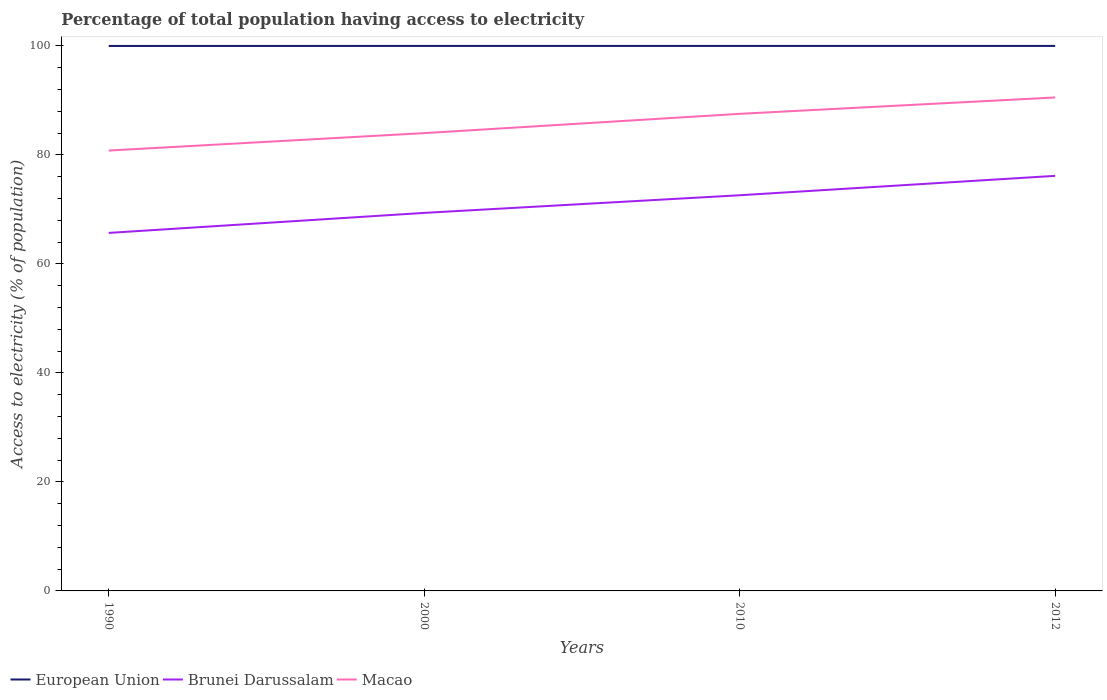How many different coloured lines are there?
Provide a short and direct response. 3. Is the number of lines equal to the number of legend labels?
Offer a very short reply. Yes. Across all years, what is the maximum percentage of population that have access to electricity in Macao?
Provide a succinct answer. 80.8. What is the total percentage of population that have access to electricity in European Union in the graph?
Keep it short and to the point. -0.01. What is the difference between the highest and the second highest percentage of population that have access to electricity in Brunei Darussalam?
Ensure brevity in your answer.  10.47. What is the difference between the highest and the lowest percentage of population that have access to electricity in Macao?
Provide a succinct answer. 2. How many lines are there?
Keep it short and to the point. 3. How many years are there in the graph?
Your answer should be very brief. 4. Are the values on the major ticks of Y-axis written in scientific E-notation?
Your response must be concise. No. Where does the legend appear in the graph?
Make the answer very short. Bottom left. How many legend labels are there?
Make the answer very short. 3. What is the title of the graph?
Offer a very short reply. Percentage of total population having access to electricity. Does "Europe(all income levels)" appear as one of the legend labels in the graph?
Your response must be concise. No. What is the label or title of the X-axis?
Your answer should be compact. Years. What is the label or title of the Y-axis?
Provide a succinct answer. Access to electricity (% of population). What is the Access to electricity (% of population) of European Union in 1990?
Offer a very short reply. 99.99. What is the Access to electricity (% of population) in Brunei Darussalam in 1990?
Give a very brief answer. 65.69. What is the Access to electricity (% of population) of Macao in 1990?
Provide a succinct answer. 80.8. What is the Access to electricity (% of population) in European Union in 2000?
Give a very brief answer. 100. What is the Access to electricity (% of population) of Brunei Darussalam in 2000?
Ensure brevity in your answer.  69.36. What is the Access to electricity (% of population) in European Union in 2010?
Ensure brevity in your answer.  100. What is the Access to electricity (% of population) of Brunei Darussalam in 2010?
Keep it short and to the point. 72.6. What is the Access to electricity (% of population) in Macao in 2010?
Make the answer very short. 87.54. What is the Access to electricity (% of population) in Brunei Darussalam in 2012?
Offer a very short reply. 76.16. What is the Access to electricity (% of population) of Macao in 2012?
Make the answer very short. 90.54. Across all years, what is the maximum Access to electricity (% of population) of European Union?
Your answer should be compact. 100. Across all years, what is the maximum Access to electricity (% of population) of Brunei Darussalam?
Offer a very short reply. 76.16. Across all years, what is the maximum Access to electricity (% of population) in Macao?
Make the answer very short. 90.54. Across all years, what is the minimum Access to electricity (% of population) of European Union?
Keep it short and to the point. 99.99. Across all years, what is the minimum Access to electricity (% of population) in Brunei Darussalam?
Your answer should be compact. 65.69. Across all years, what is the minimum Access to electricity (% of population) in Macao?
Provide a short and direct response. 80.8. What is the total Access to electricity (% of population) in European Union in the graph?
Provide a short and direct response. 399.99. What is the total Access to electricity (% of population) of Brunei Darussalam in the graph?
Keep it short and to the point. 283.82. What is the total Access to electricity (% of population) of Macao in the graph?
Offer a very short reply. 342.89. What is the difference between the Access to electricity (% of population) of European Union in 1990 and that in 2000?
Your answer should be compact. -0.01. What is the difference between the Access to electricity (% of population) of Brunei Darussalam in 1990 and that in 2000?
Provide a short and direct response. -3.67. What is the difference between the Access to electricity (% of population) of Macao in 1990 and that in 2000?
Your answer should be very brief. -3.2. What is the difference between the Access to electricity (% of population) in European Union in 1990 and that in 2010?
Provide a succinct answer. -0.01. What is the difference between the Access to electricity (% of population) in Brunei Darussalam in 1990 and that in 2010?
Your answer should be very brief. -6.91. What is the difference between the Access to electricity (% of population) of Macao in 1990 and that in 2010?
Offer a terse response. -6.74. What is the difference between the Access to electricity (% of population) of European Union in 1990 and that in 2012?
Ensure brevity in your answer.  -0.01. What is the difference between the Access to electricity (% of population) of Brunei Darussalam in 1990 and that in 2012?
Offer a terse response. -10.47. What is the difference between the Access to electricity (% of population) in Macao in 1990 and that in 2012?
Offer a very short reply. -9.74. What is the difference between the Access to electricity (% of population) in European Union in 2000 and that in 2010?
Make the answer very short. 0. What is the difference between the Access to electricity (% of population) of Brunei Darussalam in 2000 and that in 2010?
Ensure brevity in your answer.  -3.24. What is the difference between the Access to electricity (% of population) in Macao in 2000 and that in 2010?
Keep it short and to the point. -3.54. What is the difference between the Access to electricity (% of population) in European Union in 2000 and that in 2012?
Provide a succinct answer. 0. What is the difference between the Access to electricity (% of population) of Brunei Darussalam in 2000 and that in 2012?
Your response must be concise. -6.8. What is the difference between the Access to electricity (% of population) of Macao in 2000 and that in 2012?
Offer a very short reply. -6.54. What is the difference between the Access to electricity (% of population) in Brunei Darussalam in 2010 and that in 2012?
Offer a terse response. -3.56. What is the difference between the Access to electricity (% of population) of Macao in 2010 and that in 2012?
Give a very brief answer. -3. What is the difference between the Access to electricity (% of population) in European Union in 1990 and the Access to electricity (% of population) in Brunei Darussalam in 2000?
Offer a terse response. 30.63. What is the difference between the Access to electricity (% of population) of European Union in 1990 and the Access to electricity (% of population) of Macao in 2000?
Provide a succinct answer. 15.99. What is the difference between the Access to electricity (% of population) of Brunei Darussalam in 1990 and the Access to electricity (% of population) of Macao in 2000?
Your answer should be very brief. -18.31. What is the difference between the Access to electricity (% of population) in European Union in 1990 and the Access to electricity (% of population) in Brunei Darussalam in 2010?
Ensure brevity in your answer.  27.39. What is the difference between the Access to electricity (% of population) of European Union in 1990 and the Access to electricity (% of population) of Macao in 2010?
Make the answer very short. 12.45. What is the difference between the Access to electricity (% of population) in Brunei Darussalam in 1990 and the Access to electricity (% of population) in Macao in 2010?
Your answer should be compact. -21.85. What is the difference between the Access to electricity (% of population) of European Union in 1990 and the Access to electricity (% of population) of Brunei Darussalam in 2012?
Your answer should be compact. 23.83. What is the difference between the Access to electricity (% of population) of European Union in 1990 and the Access to electricity (% of population) of Macao in 2012?
Ensure brevity in your answer.  9.45. What is the difference between the Access to electricity (% of population) in Brunei Darussalam in 1990 and the Access to electricity (% of population) in Macao in 2012?
Your answer should be compact. -24.85. What is the difference between the Access to electricity (% of population) in European Union in 2000 and the Access to electricity (% of population) in Brunei Darussalam in 2010?
Keep it short and to the point. 27.4. What is the difference between the Access to electricity (% of population) of European Union in 2000 and the Access to electricity (% of population) of Macao in 2010?
Make the answer very short. 12.46. What is the difference between the Access to electricity (% of population) of Brunei Darussalam in 2000 and the Access to electricity (% of population) of Macao in 2010?
Provide a succinct answer. -18.18. What is the difference between the Access to electricity (% of population) of European Union in 2000 and the Access to electricity (% of population) of Brunei Darussalam in 2012?
Your answer should be compact. 23.84. What is the difference between the Access to electricity (% of population) in European Union in 2000 and the Access to electricity (% of population) in Macao in 2012?
Your answer should be compact. 9.46. What is the difference between the Access to electricity (% of population) of Brunei Darussalam in 2000 and the Access to electricity (% of population) of Macao in 2012?
Ensure brevity in your answer.  -21.18. What is the difference between the Access to electricity (% of population) in European Union in 2010 and the Access to electricity (% of population) in Brunei Darussalam in 2012?
Offer a very short reply. 23.84. What is the difference between the Access to electricity (% of population) in European Union in 2010 and the Access to electricity (% of population) in Macao in 2012?
Your answer should be compact. 9.46. What is the difference between the Access to electricity (% of population) of Brunei Darussalam in 2010 and the Access to electricity (% of population) of Macao in 2012?
Give a very brief answer. -17.94. What is the average Access to electricity (% of population) in European Union per year?
Offer a terse response. 100. What is the average Access to electricity (% of population) of Brunei Darussalam per year?
Ensure brevity in your answer.  70.95. What is the average Access to electricity (% of population) in Macao per year?
Ensure brevity in your answer.  85.72. In the year 1990, what is the difference between the Access to electricity (% of population) of European Union and Access to electricity (% of population) of Brunei Darussalam?
Give a very brief answer. 34.3. In the year 1990, what is the difference between the Access to electricity (% of population) in European Union and Access to electricity (% of population) in Macao?
Your answer should be very brief. 19.19. In the year 1990, what is the difference between the Access to electricity (% of population) of Brunei Darussalam and Access to electricity (% of population) of Macao?
Offer a very short reply. -15.11. In the year 2000, what is the difference between the Access to electricity (% of population) in European Union and Access to electricity (% of population) in Brunei Darussalam?
Keep it short and to the point. 30.64. In the year 2000, what is the difference between the Access to electricity (% of population) of European Union and Access to electricity (% of population) of Macao?
Give a very brief answer. 16. In the year 2000, what is the difference between the Access to electricity (% of population) in Brunei Darussalam and Access to electricity (% of population) in Macao?
Make the answer very short. -14.64. In the year 2010, what is the difference between the Access to electricity (% of population) in European Union and Access to electricity (% of population) in Brunei Darussalam?
Provide a short and direct response. 27.4. In the year 2010, what is the difference between the Access to electricity (% of population) of European Union and Access to electricity (% of population) of Macao?
Offer a very short reply. 12.46. In the year 2010, what is the difference between the Access to electricity (% of population) of Brunei Darussalam and Access to electricity (% of population) of Macao?
Ensure brevity in your answer.  -14.94. In the year 2012, what is the difference between the Access to electricity (% of population) of European Union and Access to electricity (% of population) of Brunei Darussalam?
Provide a succinct answer. 23.84. In the year 2012, what is the difference between the Access to electricity (% of population) in European Union and Access to electricity (% of population) in Macao?
Your response must be concise. 9.46. In the year 2012, what is the difference between the Access to electricity (% of population) in Brunei Darussalam and Access to electricity (% of population) in Macao?
Provide a short and direct response. -14.38. What is the ratio of the Access to electricity (% of population) in European Union in 1990 to that in 2000?
Give a very brief answer. 1. What is the ratio of the Access to electricity (% of population) in Brunei Darussalam in 1990 to that in 2000?
Ensure brevity in your answer.  0.95. What is the ratio of the Access to electricity (% of population) in Macao in 1990 to that in 2000?
Provide a short and direct response. 0.96. What is the ratio of the Access to electricity (% of population) of Brunei Darussalam in 1990 to that in 2010?
Your response must be concise. 0.9. What is the ratio of the Access to electricity (% of population) of Macao in 1990 to that in 2010?
Your response must be concise. 0.92. What is the ratio of the Access to electricity (% of population) in European Union in 1990 to that in 2012?
Your answer should be compact. 1. What is the ratio of the Access to electricity (% of population) of Brunei Darussalam in 1990 to that in 2012?
Provide a succinct answer. 0.86. What is the ratio of the Access to electricity (% of population) of Macao in 1990 to that in 2012?
Offer a terse response. 0.89. What is the ratio of the Access to electricity (% of population) in Brunei Darussalam in 2000 to that in 2010?
Keep it short and to the point. 0.96. What is the ratio of the Access to electricity (% of population) of Macao in 2000 to that in 2010?
Give a very brief answer. 0.96. What is the ratio of the Access to electricity (% of population) of European Union in 2000 to that in 2012?
Your response must be concise. 1. What is the ratio of the Access to electricity (% of population) in Brunei Darussalam in 2000 to that in 2012?
Offer a very short reply. 0.91. What is the ratio of the Access to electricity (% of population) in Macao in 2000 to that in 2012?
Your answer should be compact. 0.93. What is the ratio of the Access to electricity (% of population) in European Union in 2010 to that in 2012?
Your answer should be compact. 1. What is the ratio of the Access to electricity (% of population) of Brunei Darussalam in 2010 to that in 2012?
Keep it short and to the point. 0.95. What is the ratio of the Access to electricity (% of population) in Macao in 2010 to that in 2012?
Provide a succinct answer. 0.97. What is the difference between the highest and the second highest Access to electricity (% of population) of European Union?
Your response must be concise. 0. What is the difference between the highest and the second highest Access to electricity (% of population) of Brunei Darussalam?
Your answer should be compact. 3.56. What is the difference between the highest and the second highest Access to electricity (% of population) in Macao?
Give a very brief answer. 3. What is the difference between the highest and the lowest Access to electricity (% of population) in European Union?
Offer a terse response. 0.01. What is the difference between the highest and the lowest Access to electricity (% of population) in Brunei Darussalam?
Your answer should be very brief. 10.47. What is the difference between the highest and the lowest Access to electricity (% of population) of Macao?
Give a very brief answer. 9.74. 